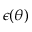<formula> <loc_0><loc_0><loc_500><loc_500>\epsilon ( \theta )</formula> 